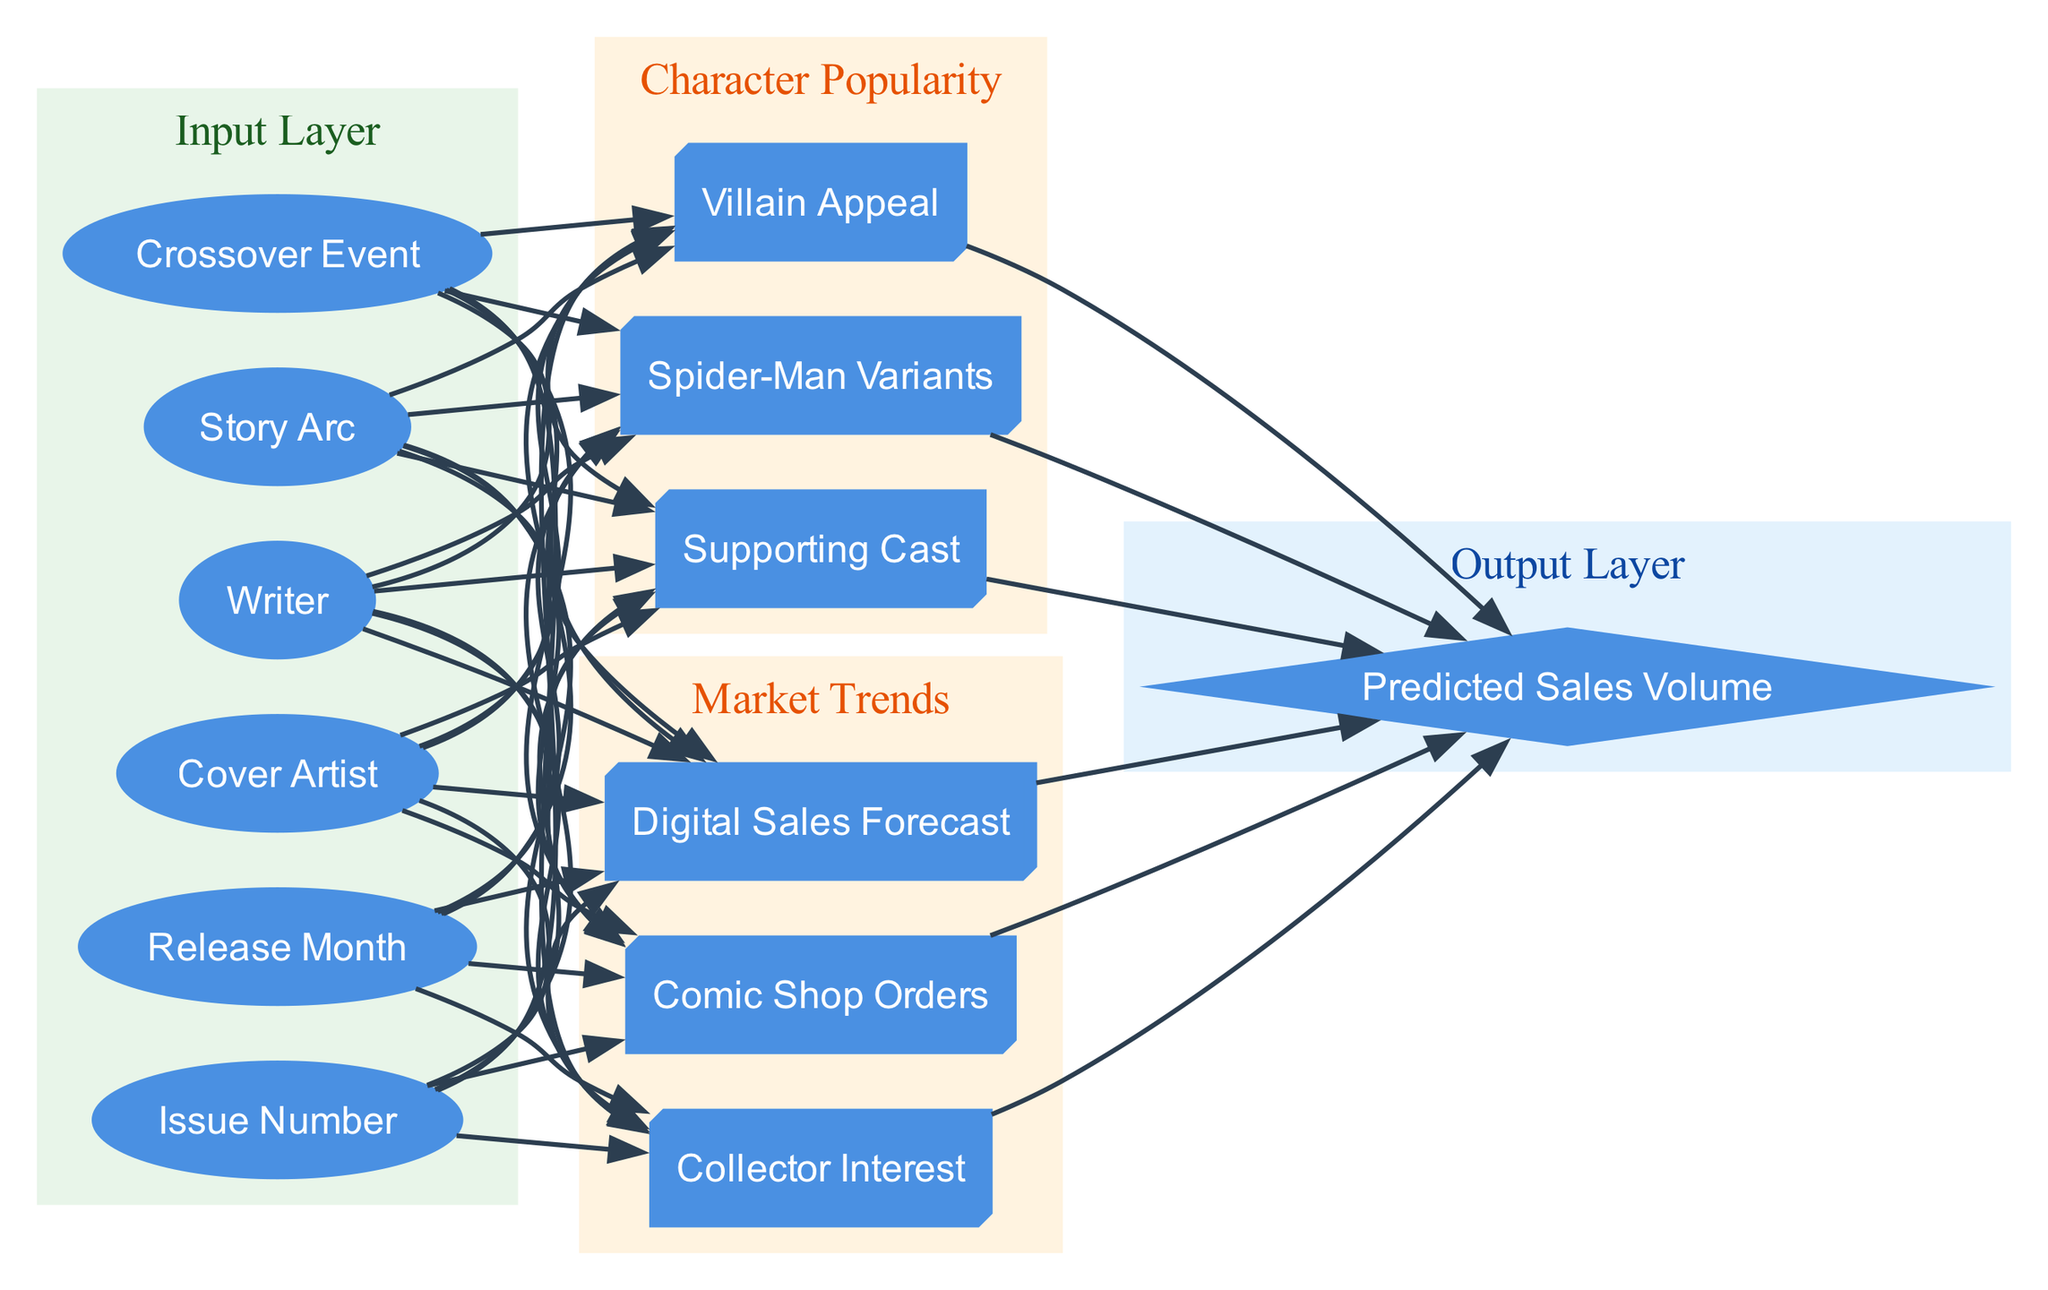What are the input nodes in this diagram? The input nodes are displayed in the input layer of the diagram, specifically listing "Cover Artist," "Writer," "Story Arc," "Crossover Event," "Issue Number," and "Release Month." These are all the variables that influence the neural network's predictions.
Answer: Cover Artist, Writer, Story Arc, Crossover Event, Issue Number, Release Month How many nodes are in the "Character Popularity" hidden layer? The "Character Popularity" hidden layer contains three nodes: "Spider-Man Variants," "Villain Appeal," and "Supporting Cast." We can count these directly from the subgraph representing this layer.
Answer: 3 What is the output node of this diagram? The diagram specifies one output node labeled "Predicted Sales Volume," which is shown in the output layer of the neural network diagram.
Answer: Predicted Sales Volume What is the relationship between 'Crossover Event' and 'Market Trends'? There is no direct connection between 'Crossover Event' and 'Market Trends' in the diagram. Instead, both are inputs that connect to separate hidden layers ("Character Popularity" and "Market Trends") leading to the output layer. This indicates they are independent variables contributing to different aspects of prediction.
Answer: None How many edges connect the input layer to the hidden layers? Each input node connects to each node in both hidden layers, leading to a calculation of the connections. With 6 input nodes and 3 nodes in "Character Popularity" and 3 in "Market Trends", we have 6 connections to each hidden layer, resulting in a total of 12 edges connecting the input layer to the hidden layers.
Answer: 12 Which hidden layer handles sales-related trends? The "Market Trends" hidden layer is responsible for handling sales-related trends, as it encompasses nodes such as "Comic Shop Orders," "Digital Sales Forecast," and "Collector Interest" that are directly related to market conditions impacting sales.
Answer: Market Trends What nodes connect directly to the "Predicted Sales Volume"? The connections leading to "Predicted Sales Volume" originate from nodes in both "Character Popularity" and "Market Trends" hidden layers. Specifically, the nodes "Spider-Man Variants," "Villain Appeal," and "Supporting Cast" from the first hidden layer, and "Comic Shop Orders," "Digital Sales Forecast," and "Collector Interest" from the second hidden layer connect directly to the output node.
Answer: Character Popularity, Market Trends How many hidden layers are shown in the diagram? The diagram presents two distinct hidden layers, which are labeled as "Character Popularity" and "Market Trends." This can be confirmed by looking at the subgraphs representing the hidden layers in the diagram.
Answer: 2 What type of nodes are used for the output layer? The output layer comprises a diamond-shaped node to represent the final prediction outcome. Specifically, it contains the node labeled "Predicted Sales Volume," which visually signifies a result or output in this neural network architecture.
Answer: Diamond-shaped node 